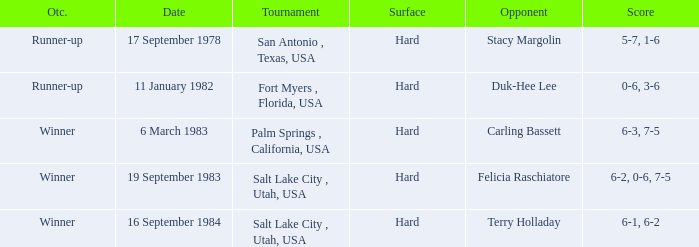Who was the opponent for the match were the outcome was runner-up and the score was 5-7, 1-6? Stacy Margolin. 